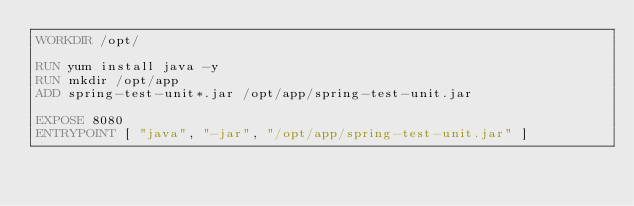<code> <loc_0><loc_0><loc_500><loc_500><_Dockerfile_>WORKDIR /opt/

RUN yum install java -y
RUN mkdir /opt/app
ADD spring-test-unit*.jar /opt/app/spring-test-unit.jar

EXPOSE 8080
ENTRYPOINT [ "java", "-jar", "/opt/app/spring-test-unit.jar" ]</code> 